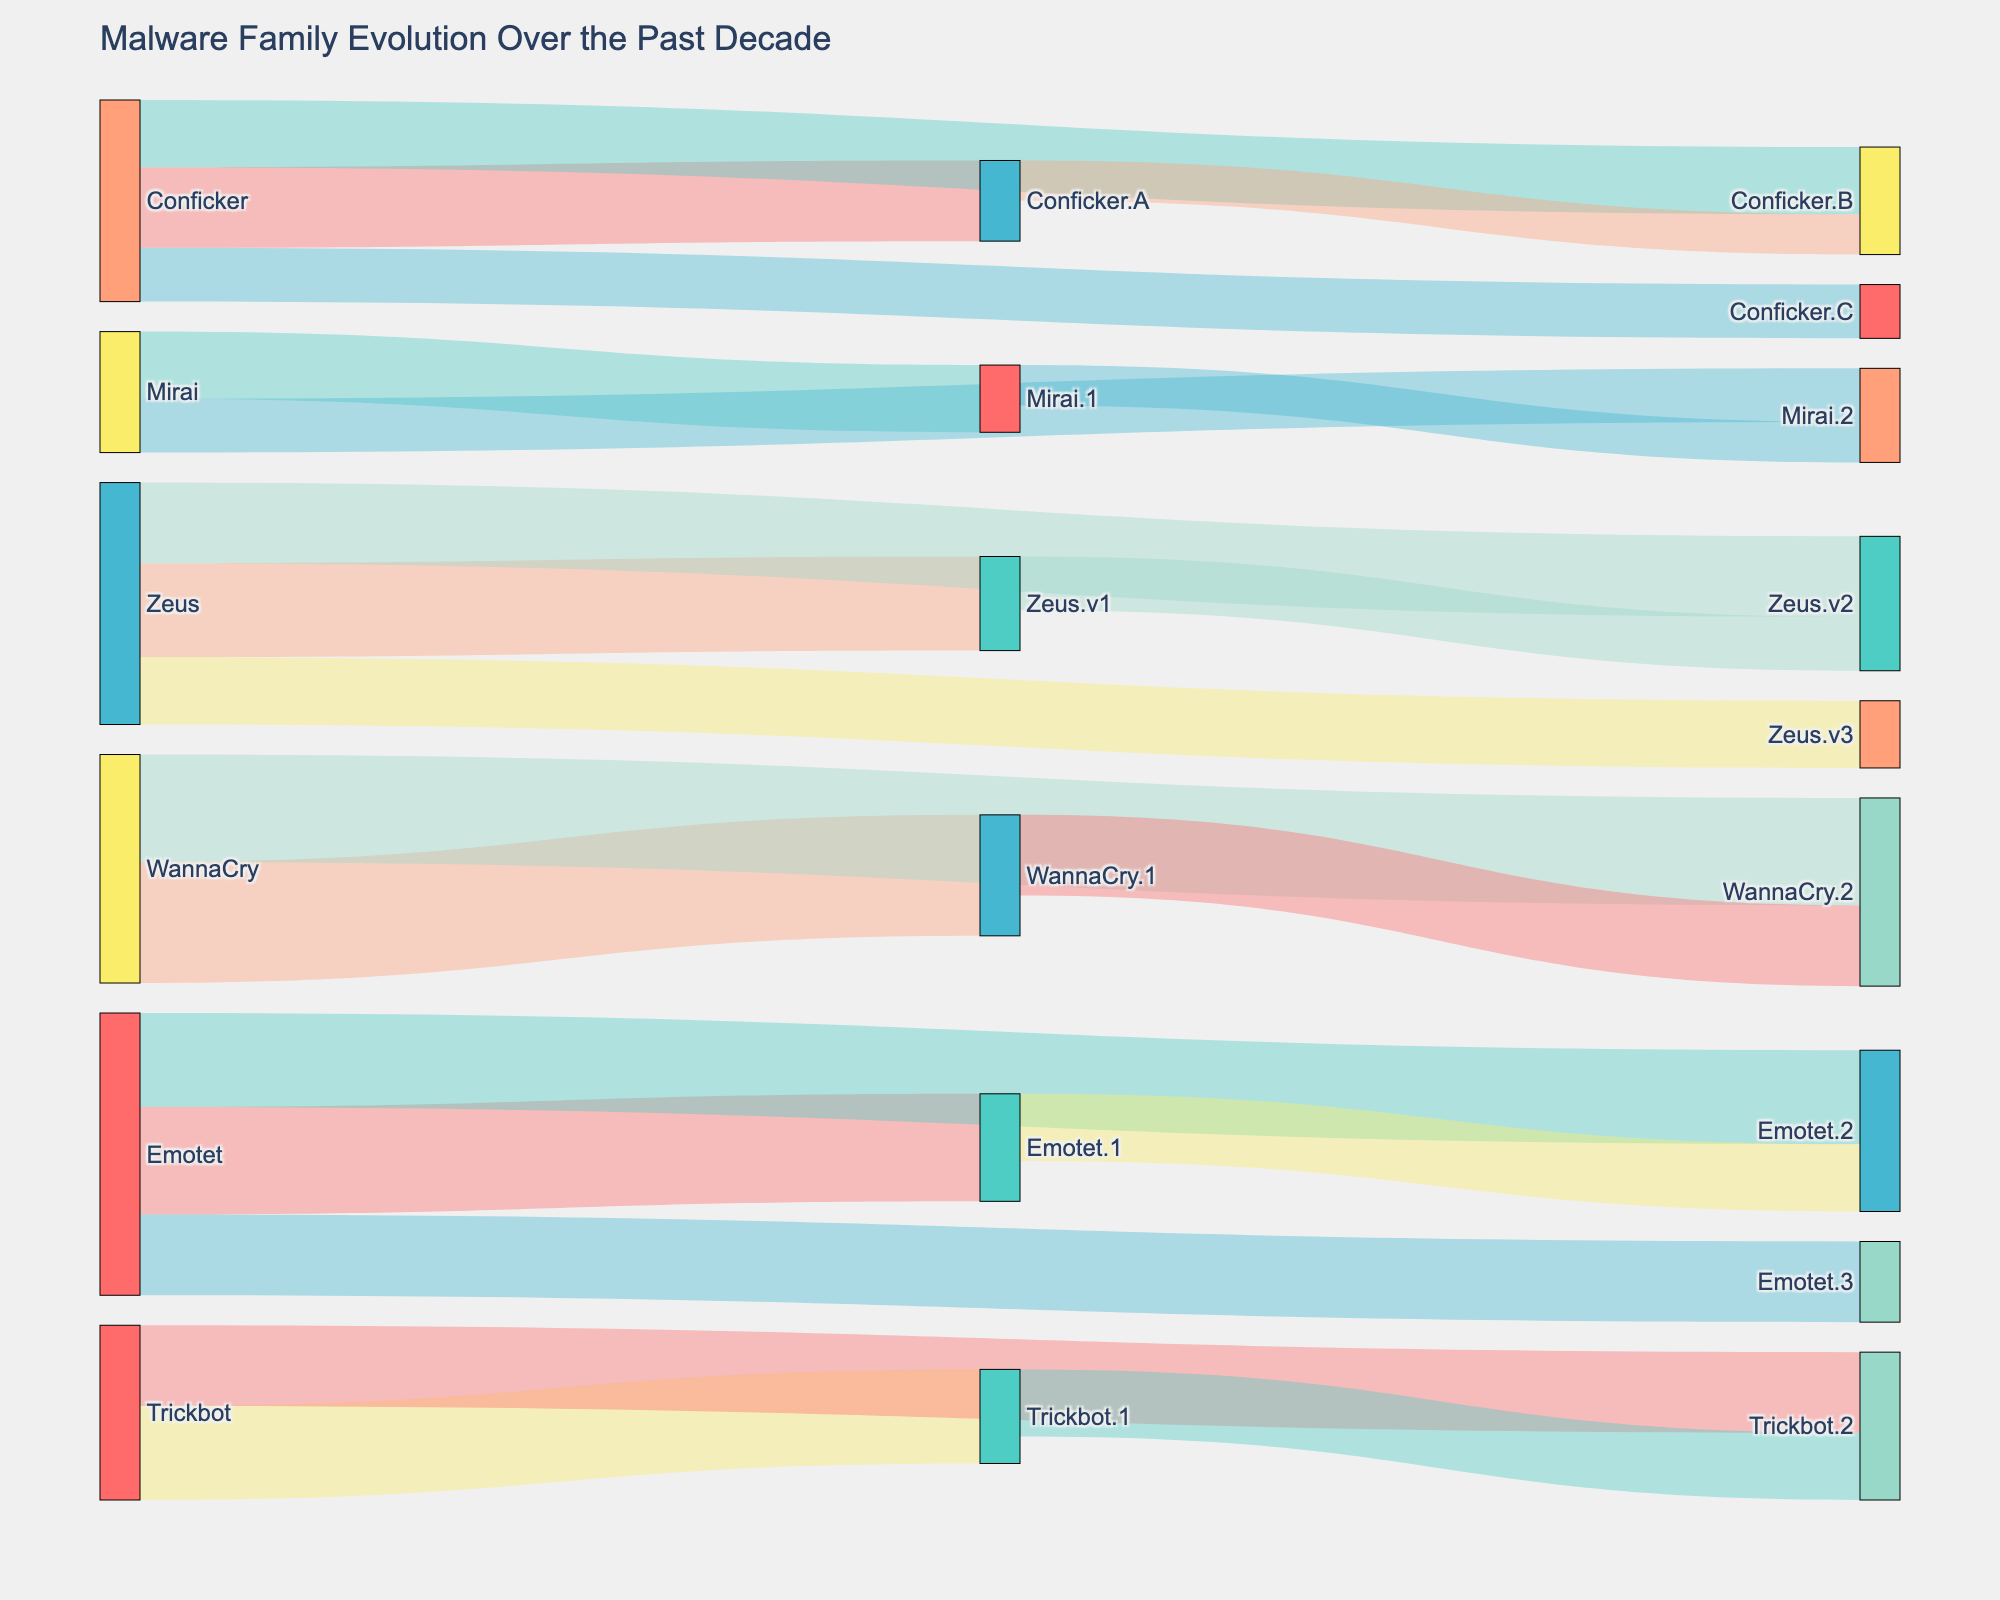What is the title of the figure? The title is usually located at the top of the figure and it typically describes the overall content.
Answer: Malware Family Evolution Over the Past Decade Which malware variant has the highest value starting from WannaCry? By observing the target nodes originating from WannaCry, WannaCry.1 has the highest value.
Answer: WannaCry.1 Compare the value of Zeus.v1 and Emotet.1. Which one is greater? By locating both Zeus.v1 and Emotet.1 in the figure, comparing their values shows that Emotet.1 has a higher value than Zeus.v1.
Answer: Emotet.1 What is the combined value of all Conficker variants? The values of Conficker variants (Conficker.A, Conficker.B, Conficker.C) are 30, 25, and 20 respectively. Summing these values: 30 + 25 + 20 = 75.
Answer: 75 How many different sources share a link with Trickbot.2? By tracing the links connected to Trickbot.2, it shows that only Trickbot.1 is linked to Trickbot.2.
Answer: 1 Which variant has evolved through the most links starting from Zeus? Observing the links originating from Zeus, it’s clear that Zeus.v2 evolves from Zeus.v1, and thus has the most links.
Answer: Zeus.v2 What is the total value of all malware targets directly linked from Emotet? The targets from Emotet are Emotet.1, Emotet.2, and Emotet.3 with values 40, 35, and 30. Summing these values: 40 + 35 + 30 = 105.
Answer: 105 Compare the number of variants that evolved from both Zeus and Mirai. Which source has more variants? Counting the variants from Zeus (Zeus.v1, Zeus.v2, Zeus.v3) and Mirai (Mirai.1, Mirai.2), Zeus has 3 variants while Mirai has 2. Thus, Zeus has more variants.
Answer: Zeus Which variant directly evolving from Conficker has the smallest value? Among the variants from Conficker, Conficker.C has the smallest value of 20.
Answer: Conficker.C List all the sub-variants evolving from Conficker.B with their respective values. The sub-variant evolving from Conficker.B is not directly listed; however, Conficker.B evolved from Conficker.A with a value of 15 ages the logical supposition. No direct sub-variants explicitly from Conficker.B are provided.
Answer: Conficker.B: 15 